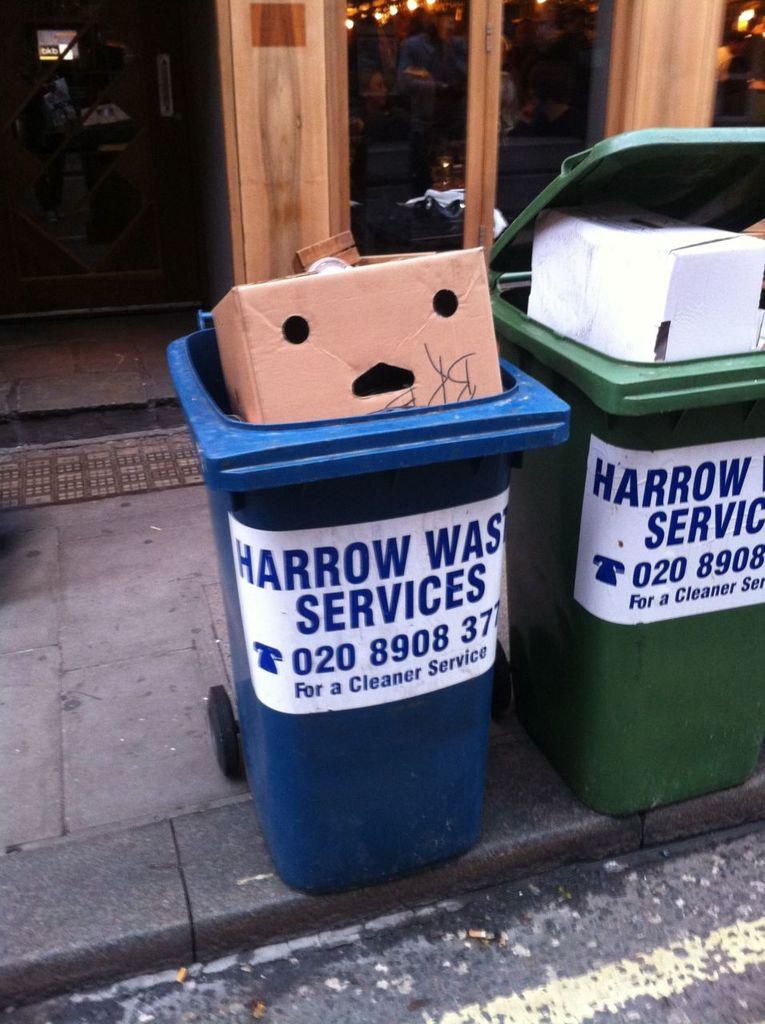What is the first three digits of the phone number on the trash can?
Ensure brevity in your answer.  020. 